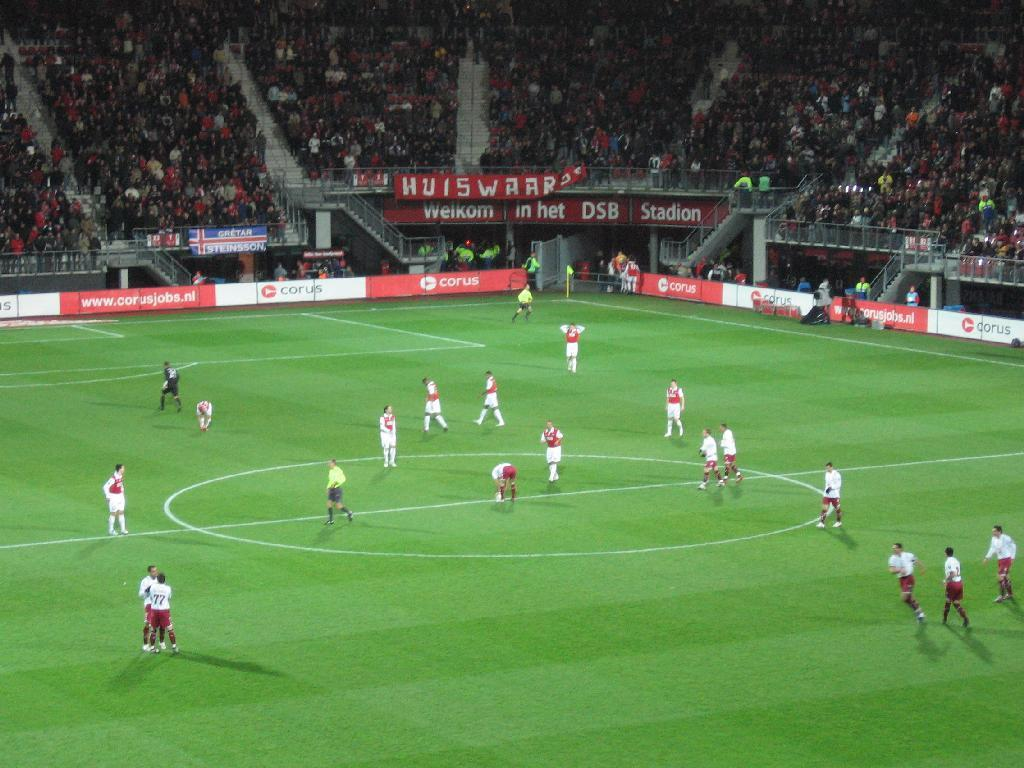Who or what can be seen in the image? There are people in the image. What type of surface is visible in the image? There is ground visible in the image. What objects are present in the image? There are boards, hoardings, and railings in the image. What can be seen in the background of the image? There is a stadium and audience members in the background of the image. What type of learning is taking place in the image? There is no indication of learning taking place in the image. Can you see an airport in the image? There is no airport present in the image. 